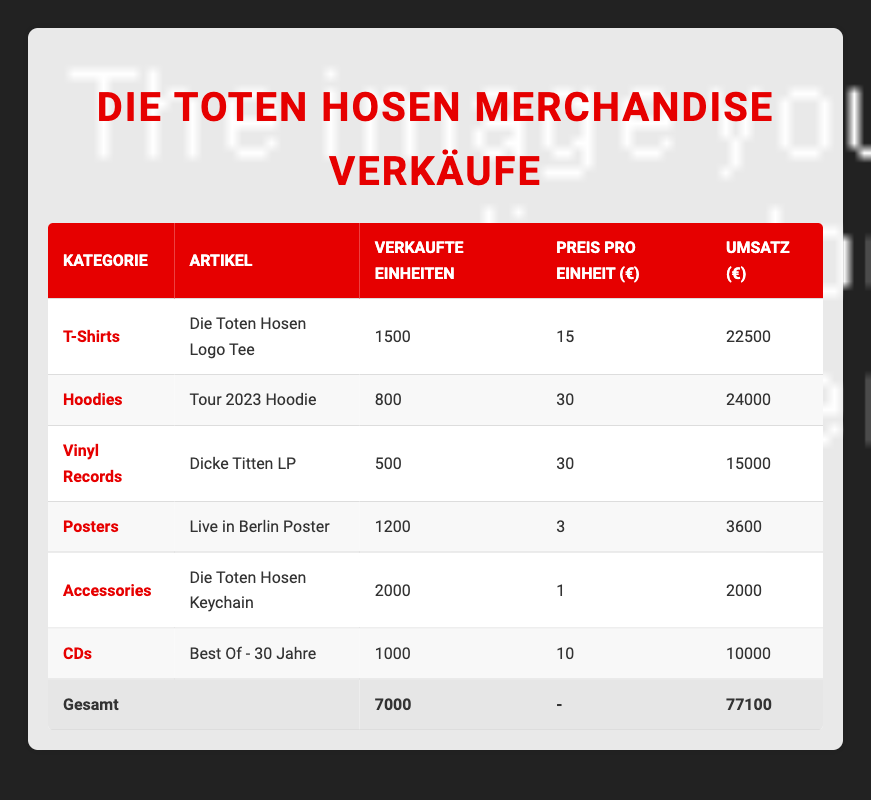What is the total revenue generated from merchandise sales? The total revenue is obtained by summing the revenue from all categories. From the table, the revenues are: 22500 (T-Shirts) + 24000 (Hoodies) + 15000 (Vinyl Records) + 3600 (Posters) + 2000 (Accessories) + 10000 (CDs) = 77100.
Answer: 77100 Which merchandise category sold the most units? The number of units sold for each category is: 1500 (T-Shirts), 800 (Hoodies), 500 (Vinyl Records), 1200 (Posters), 2000 (Accessories), and 1000 (CDs). The highest value is 2000 for Accessories.
Answer: Accessories What is the price per unit of the "Tour 2023 Hoodie"? The price per unit is stated directly in the table for each item. For the "Tour 2023 Hoodie," the price per unit is 30.
Answer: 30 Is the total units sold for all categories more than 5000? To answer this, sum up the units sold from all categories: 1500 + 800 + 500 + 1200 + 2000 + 1000 = 7000, which is greater than 5000.
Answer: Yes What is the average revenue per category? The average revenue can be calculated by dividing the total revenue by the number of categories. The total revenue is 77100 and there are 6 categories. Thus, the average revenue is 77100 / 6 ≈ 12850.
Answer: 12850 How many more units of "Die Toten Hosen Logo Tee" were sold compared to "Dicke Titten LP"? "Die Toten Hosen Logo Tee" sold 1500 units and "Dicke Titten LP" sold 500 units. The difference is 1500 - 500 = 1000.
Answer: 1000 What percentage of the total revenue comes from T-Shirt sales? To find the percentage from T-Shirts, divide the revenue from T-Shirts by the total revenue and multiply by 100. T-Shirt revenue is 22500, so (22500 / 77100) * 100 ≈ 29.2%.
Answer: 29.2% Did more items sell in the Accessories category compared to T-Shirts? The Accessories sold 2000 units, and T-Shirts sold 1500 units. Since 2000 is greater than 1500, the answer is yes.
Answer: Yes Which category generated the least revenue? The revenues are 22500 (T-Shirts), 24000 (Hoodies), 15000 (Vinyl Records), 3600 (Posters), 2000 (Accessories), and 10000 (CDs). The lowest revenue is 2000 from the Accessories category.
Answer: Accessories 